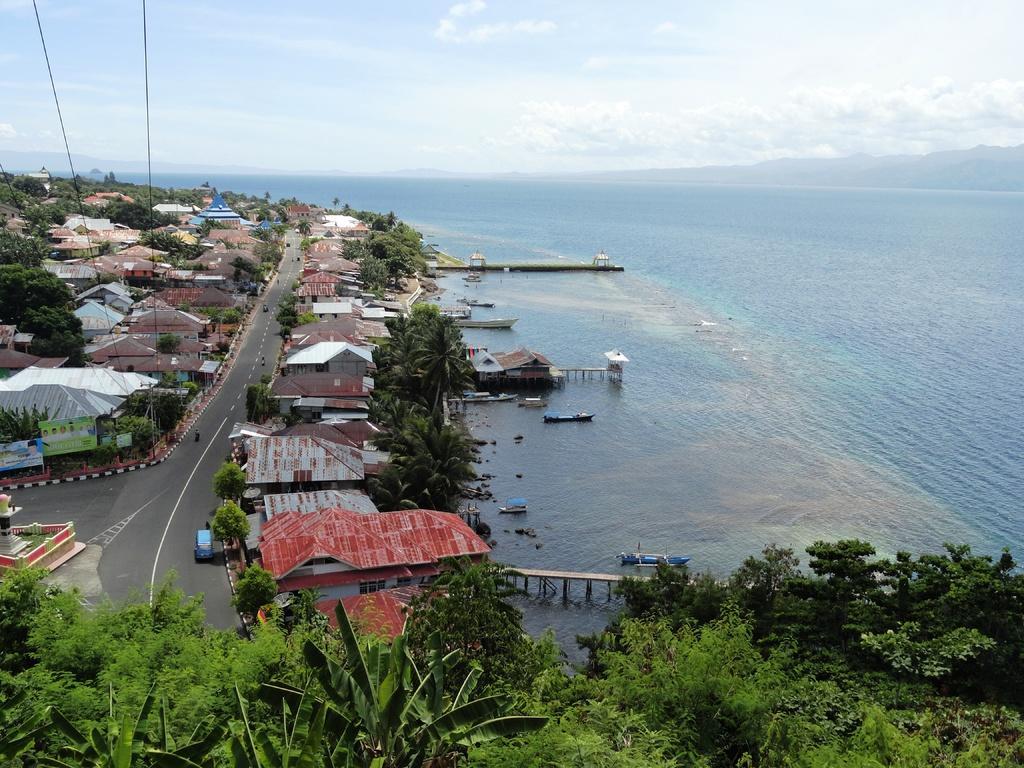In one or two sentences, can you explain what this image depicts? This image consists of many houses. At the bottom, we can see a road. On the right, there is an ocean. And we can see many trees in this image. At the top, there are clouds in the sky. It looks like it is clicked from top view. 